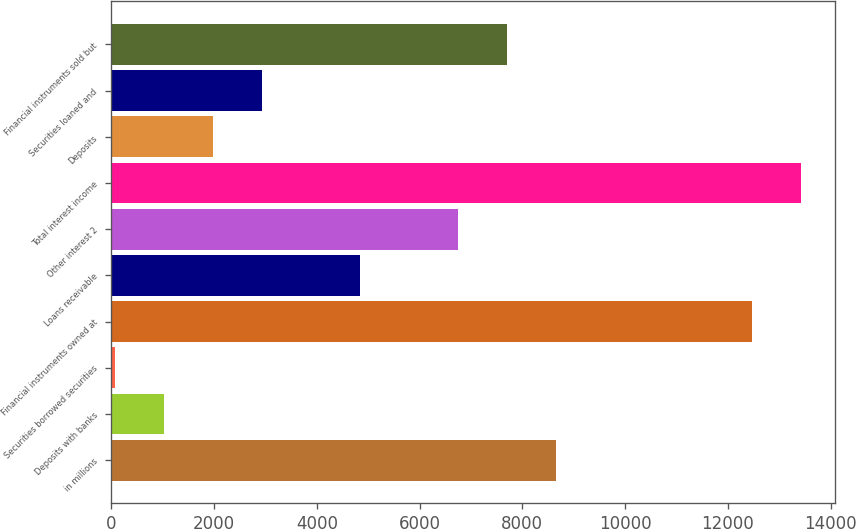<chart> <loc_0><loc_0><loc_500><loc_500><bar_chart><fcel>in millions<fcel>Deposits with banks<fcel>Securities borrowed securities<fcel>Financial instruments owned at<fcel>Loans receivable<fcel>Other interest 2<fcel>Total interest income<fcel>Deposits<fcel>Securities loaned and<fcel>Financial instruments sold but<nl><fcel>8651.7<fcel>1033.3<fcel>81<fcel>12460.9<fcel>4842.5<fcel>6747.1<fcel>13413.2<fcel>1985.6<fcel>2937.9<fcel>7699.4<nl></chart> 